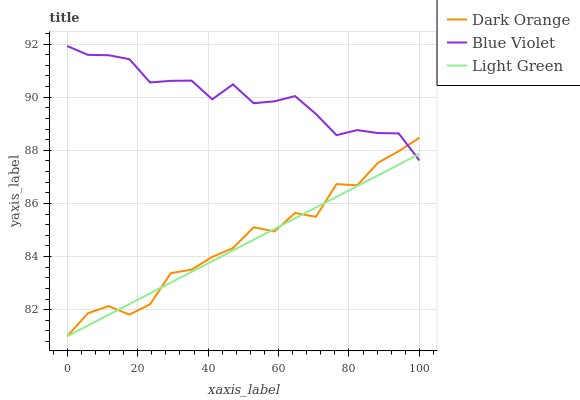Does Light Green have the minimum area under the curve?
Answer yes or no. Yes. Does Blue Violet have the maximum area under the curve?
Answer yes or no. Yes. Does Blue Violet have the minimum area under the curve?
Answer yes or no. No. Does Light Green have the maximum area under the curve?
Answer yes or no. No. Is Light Green the smoothest?
Answer yes or no. Yes. Is Dark Orange the roughest?
Answer yes or no. Yes. Is Blue Violet the smoothest?
Answer yes or no. No. Is Blue Violet the roughest?
Answer yes or no. No. Does Dark Orange have the lowest value?
Answer yes or no. Yes. Does Blue Violet have the lowest value?
Answer yes or no. No. Does Blue Violet have the highest value?
Answer yes or no. Yes. Does Light Green have the highest value?
Answer yes or no. No. Does Blue Violet intersect Light Green?
Answer yes or no. Yes. Is Blue Violet less than Light Green?
Answer yes or no. No. Is Blue Violet greater than Light Green?
Answer yes or no. No. 